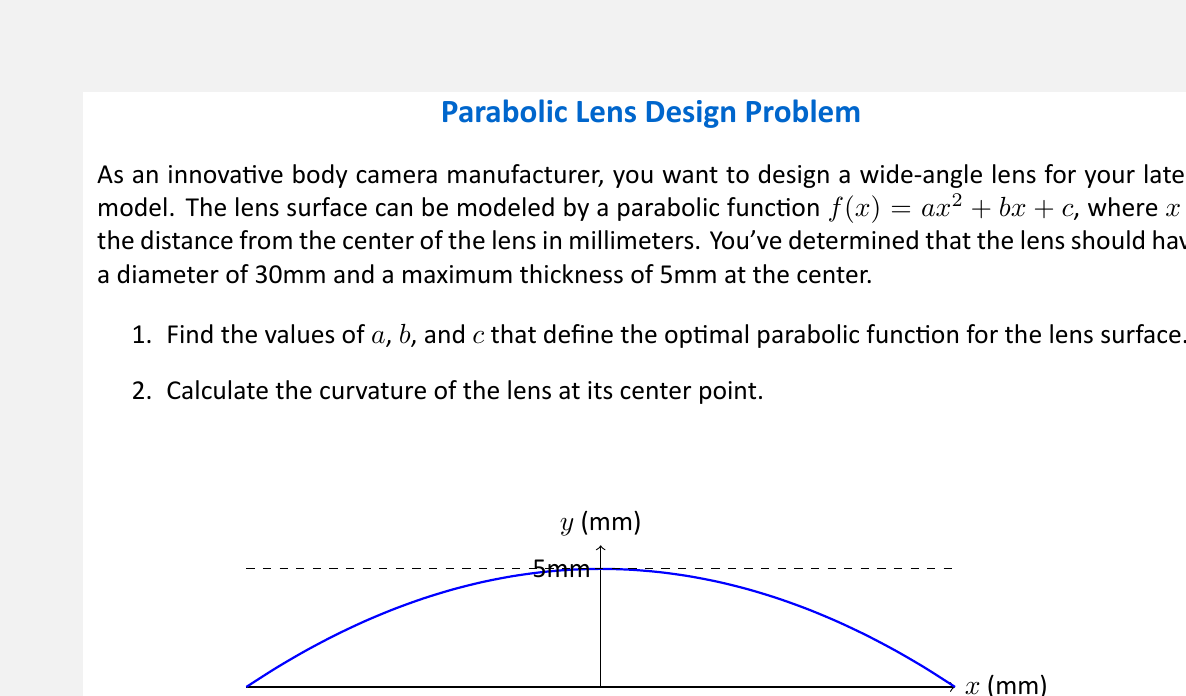Can you answer this question? Let's approach this problem step by step:

1. Finding the parabolic function:
   
   a) The general form of the parabola is $f(x) = ax^2 + bx + c$.
   
   b) Since the lens is symmetrical, $b = 0$.
   
   c) The maximum thickness is at the center, so $c = 5$.
   
   d) The parabola passes through the points $(15, 0)$ and $(-15, 0)$, as the diameter is 30mm.
   
   e) We can use the point $(15, 0)$ to find $a$:
      
      $$0 = a(15)^2 + 5$$
      $$0 = 225a + 5$$
      $$-5 = 225a$$
      $$a = -\frac{5}{225} = -0.0222222$$

   f) Therefore, the parabolic function is:
      
      $$f(x) = -0.0222222x^2 + 5$$

2. Calculating the curvature:
   
   a) The formula for curvature $K$ at any point $(x, f(x))$ is:
      
      $$K = \frac{|f''(x)|}{(1 + (f'(x))^2)^{3/2}}$$

   b) We need to find $f'(x)$ and $f''(x)$:
      
      $$f'(x) = -0.0444444x$$
      $$f''(x) = -0.0444444$$

   c) At the center point $(0, 5)$:
      
      $$f'(0) = 0$$
      $$f''(0) = -0.0444444$$

   d) Substituting into the curvature formula:
      
      $$K = \frac{|-0.0444444|}{(1 + 0^2)^{3/2}} = 0.0444444$$
Answer: 1) $f(x) = -0.0222222x^2 + 5$
2) $K = 0.0444444$ mm$^{-1}$ 